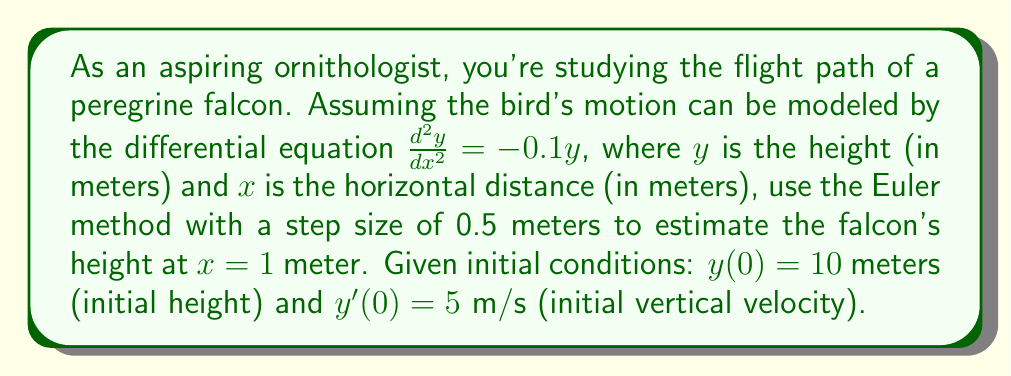Help me with this question. To solve this problem using the Euler method, we need to convert the second-order differential equation into a system of first-order equations:

Let $y_1 = y$ and $y_2 = \frac{dy}{dx}$. Then:

$$\frac{dy_1}{dx} = y_2$$
$$\frac{dy_2}{dx} = -0.1y_1$$

Initial conditions: $y_1(0) = 10$, $y_2(0) = 5$

The Euler method for a system of equations is:

$$y_{1,n+1} = y_{1,n} + h \cdot f_1(x_n, y_{1,n}, y_{2,n})$$
$$y_{2,n+1} = y_{2,n} + h \cdot f_2(x_n, y_{1,n}, y_{2,n})$$

Where $h$ is the step size (0.5 m), and $f_1$ and $f_2$ are the right-hand sides of our system of equations.

Step 1: Calculate $y_1$ and $y_2$ at $x = 0.5$
$$y_{1,1} = 10 + 0.5 \cdot 5 = 12.5$$
$$y_{2,1} = 5 + 0.5 \cdot (-0.1 \cdot 10) = 4.5$$

Step 2: Calculate $y_1$ and $y_2$ at $x = 1$
$$y_{1,2} = 12.5 + 0.5 \cdot 4.5 = 14.75$$
$$y_{2,2} = 4.5 + 0.5 \cdot (-0.1 \cdot 12.5) = 3.875$$

The estimated height of the falcon at $x = 1$ meter is $y_{1,2} = 14.75$ meters.
Answer: 14.75 meters 